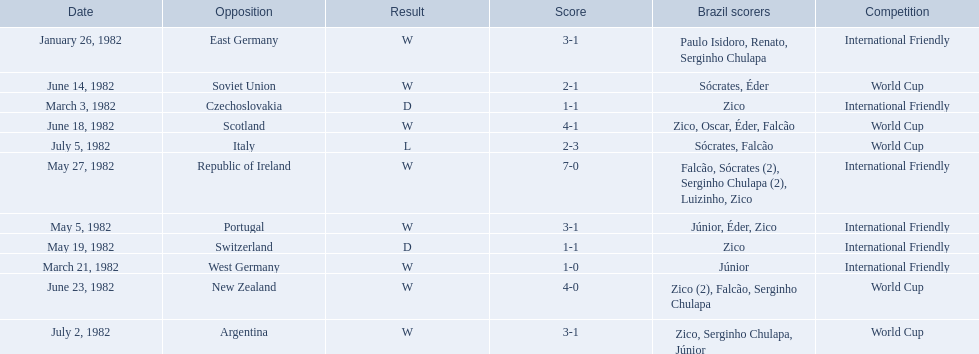What are all the dates of games in 1982 in brazilian football? January 26, 1982, March 3, 1982, March 21, 1982, May 5, 1982, May 19, 1982, May 27, 1982, June 14, 1982, June 18, 1982, June 23, 1982, July 2, 1982, July 5, 1982. Which of these dates is at the top of the chart? January 26, 1982. 